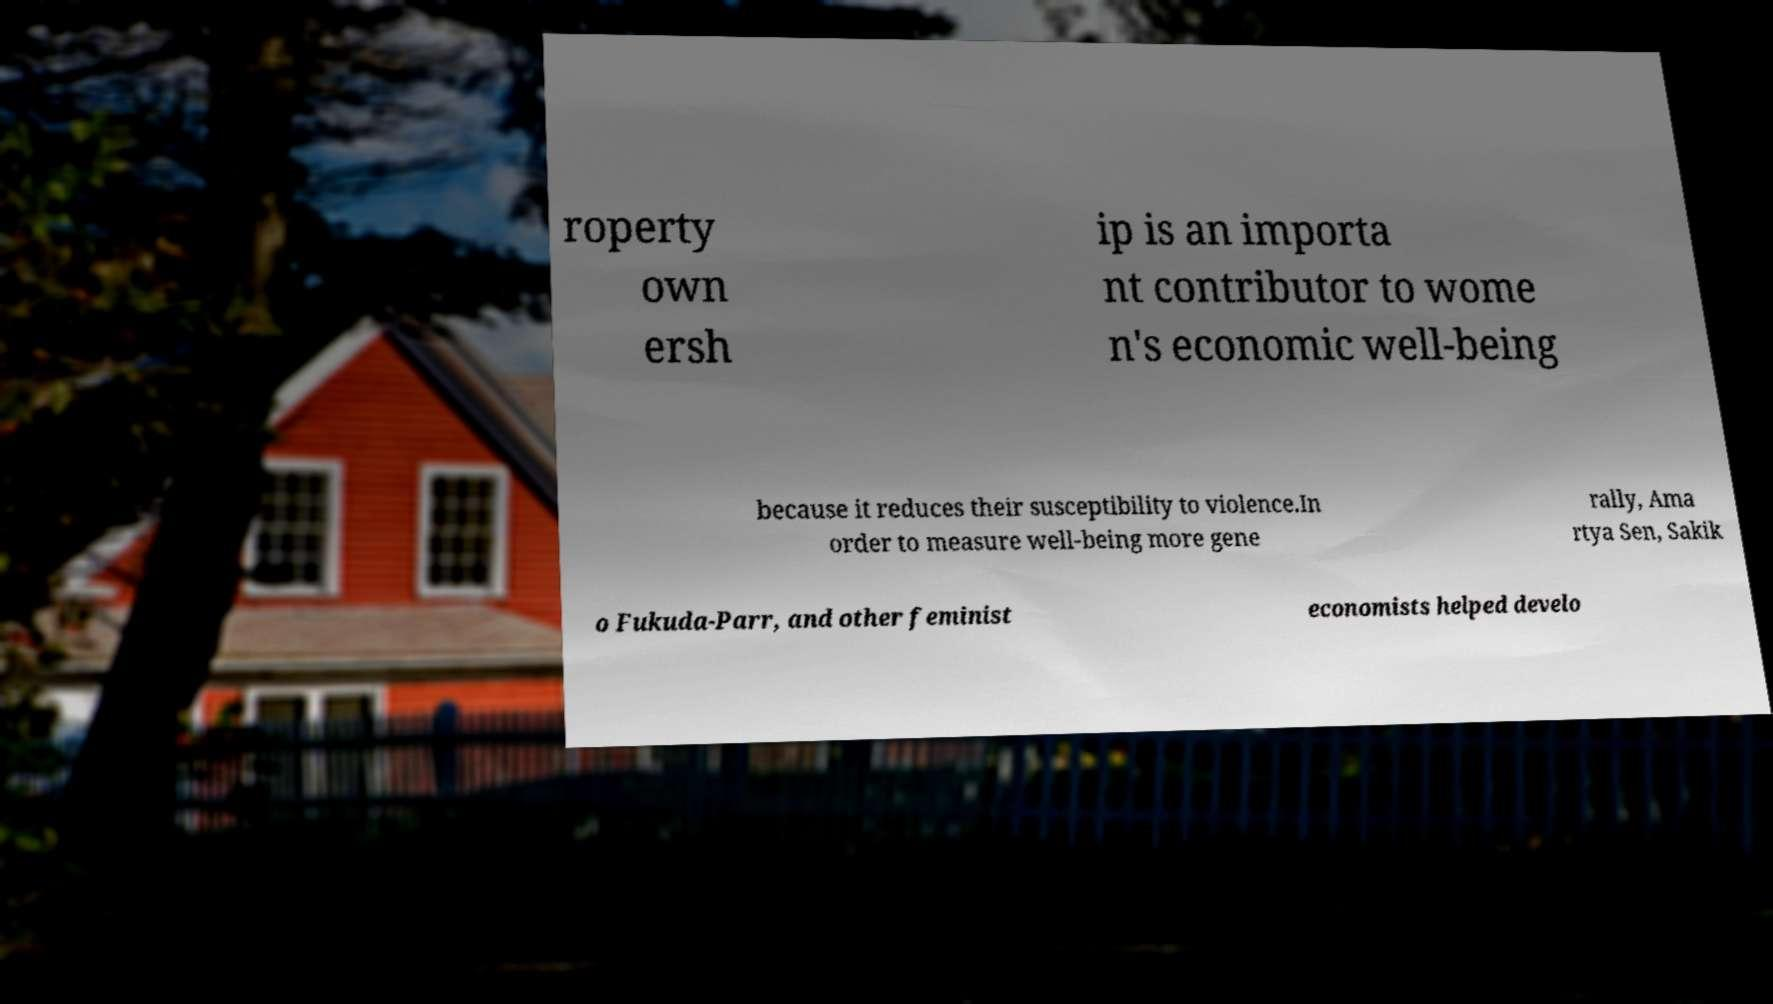What messages or text are displayed in this image? I need them in a readable, typed format. roperty own ersh ip is an importa nt contributor to wome n's economic well-being because it reduces their susceptibility to violence.In order to measure well-being more gene rally, Ama rtya Sen, Sakik o Fukuda-Parr, and other feminist economists helped develo 